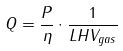<formula> <loc_0><loc_0><loc_500><loc_500>Q = \frac { P } { \eta } \cdot \frac { 1 } { L H V _ { g a s } }</formula> 